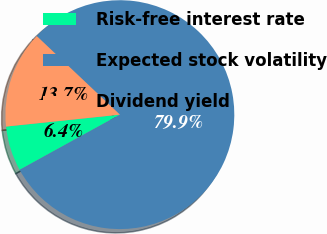Convert chart to OTSL. <chart><loc_0><loc_0><loc_500><loc_500><pie_chart><fcel>Risk-free interest rate<fcel>Expected stock volatility<fcel>Dividend yield<nl><fcel>6.35%<fcel>79.94%<fcel>13.71%<nl></chart> 